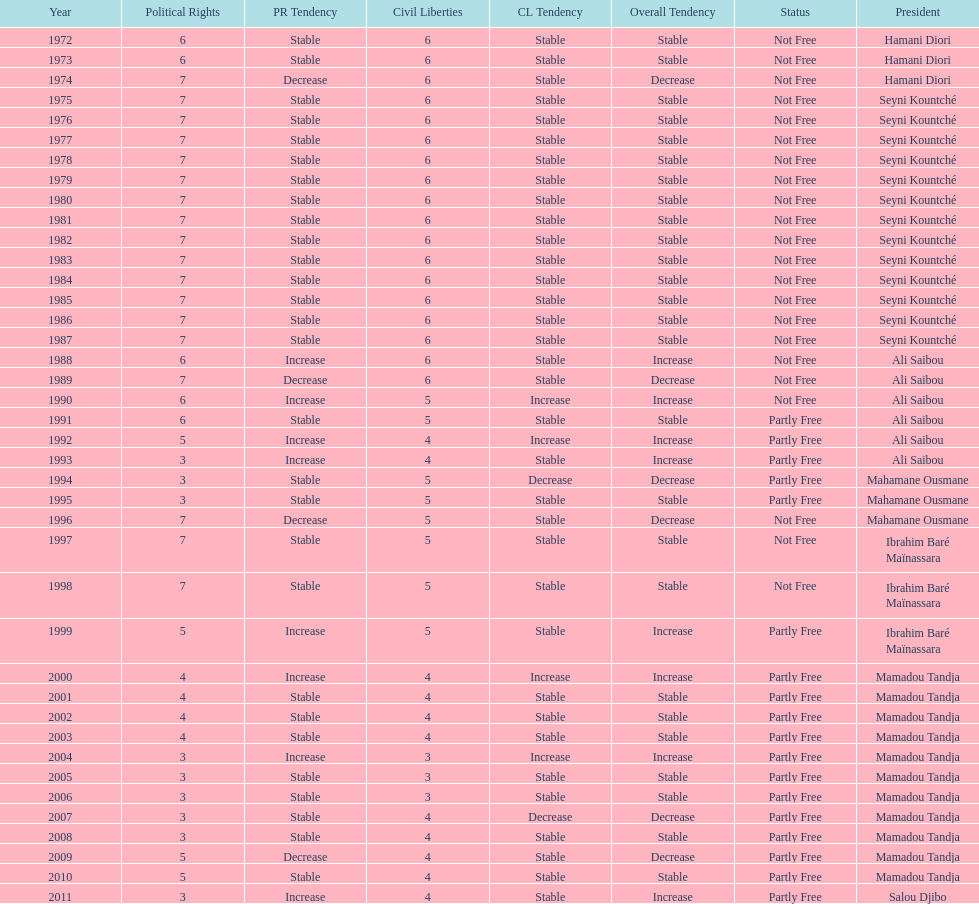How long did it take for civil liberties to decrease below 6? 18 years. 